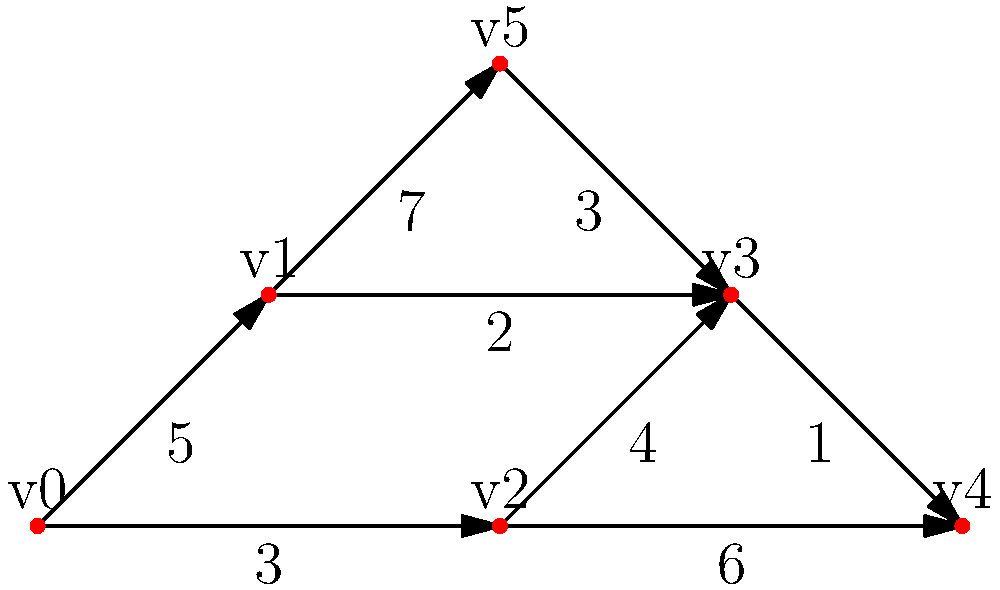Given the network topology shown in the diagram, where vertices represent routers and edge weights represent transmission delays in milliseconds, what is the minimum total delay for a packet to travel from router $v_0$ to router $v_4$ using Dijkstra's algorithm? Additionally, provide the optimal path. To solve this problem, we'll apply Dijkstra's algorithm to find the shortest path from $v_0$ to $v_4$:

1) Initialize:
   - Set distance to $v_0$ as 0, and all others as infinity.
   - Set all nodes as unvisited.
   - Set $v_0$ as the current node.

2) For the current node, consider all unvisited neighbors and calculate their tentative distances:
   - $v_0$ to $v_1$: 5 ms
   - $v_0$ to $v_2$: 3 ms

3) Mark $v_0$ as visited. $v_2$ has the smallest tentative distance, so make it the current node.

4) From $v_2$:
   - $v_2$ to $v_3$: 3 + 4 = 7 ms
   - $v_2$ to $v_4$: 3 + 6 = 9 ms

5) Mark $v_2$ as visited. $v_1$ has the smallest tentative distance among unvisited nodes, so it becomes current.

6) From $v_1$:
   - $v_1$ to $v_3$: 5 + 2 = 7 ms (no change)
   - $v_1$ to $v_5$: 5 + 7 = 12 ms

7) Mark $v_1$ as visited. $v_3$ becomes the current node.

8) From $v_3$:
   - $v_3$ to $v_4$: 7 + 1 = 8 ms (update from 9 ms)
   - $v_3$ to $v_5$: 7 + 3 = 10 ms (update from 12 ms)

9) Mark $v_3$ as visited. $v_4$ becomes the current node.

The algorithm terminates as we've reached the destination $v_4$. The minimum total delay is 8 ms, and the optimal path is $v_0 \rightarrow v_2 \rightarrow v_3 \rightarrow v_4$.
Answer: 8 ms; Path: $v_0 \rightarrow v_2 \rightarrow v_3 \rightarrow v_4$ 